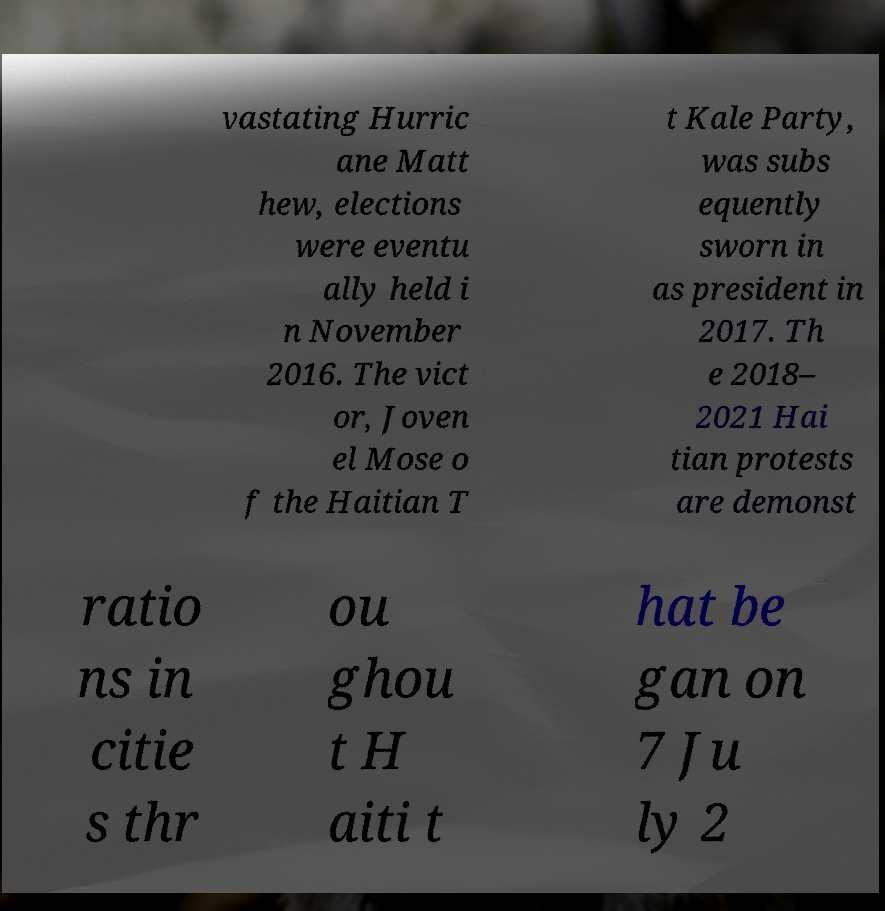Please identify and transcribe the text found in this image. vastating Hurric ane Matt hew, elections were eventu ally held i n November 2016. The vict or, Joven el Mose o f the Haitian T t Kale Party, was subs equently sworn in as president in 2017. Th e 2018– 2021 Hai tian protests are demonst ratio ns in citie s thr ou ghou t H aiti t hat be gan on 7 Ju ly 2 